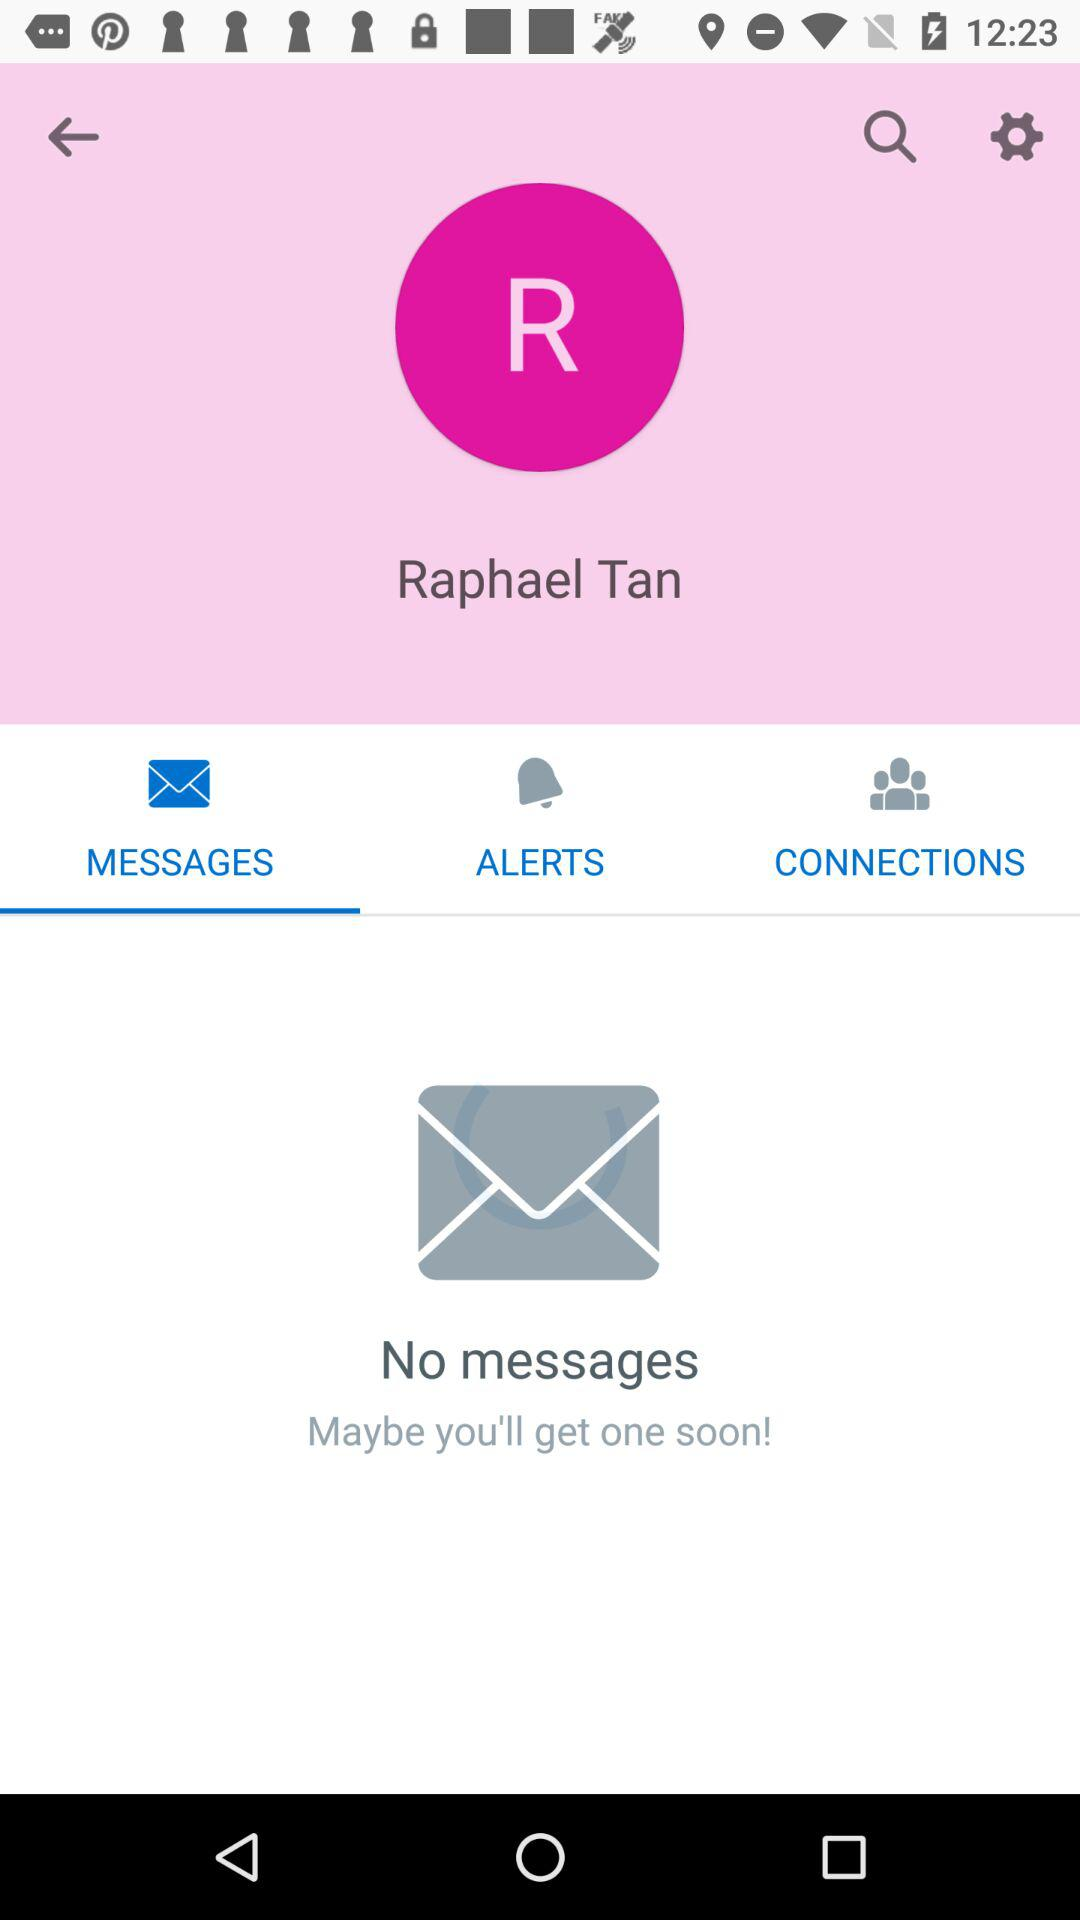What is the user name? The user name is Raphael Tan. 